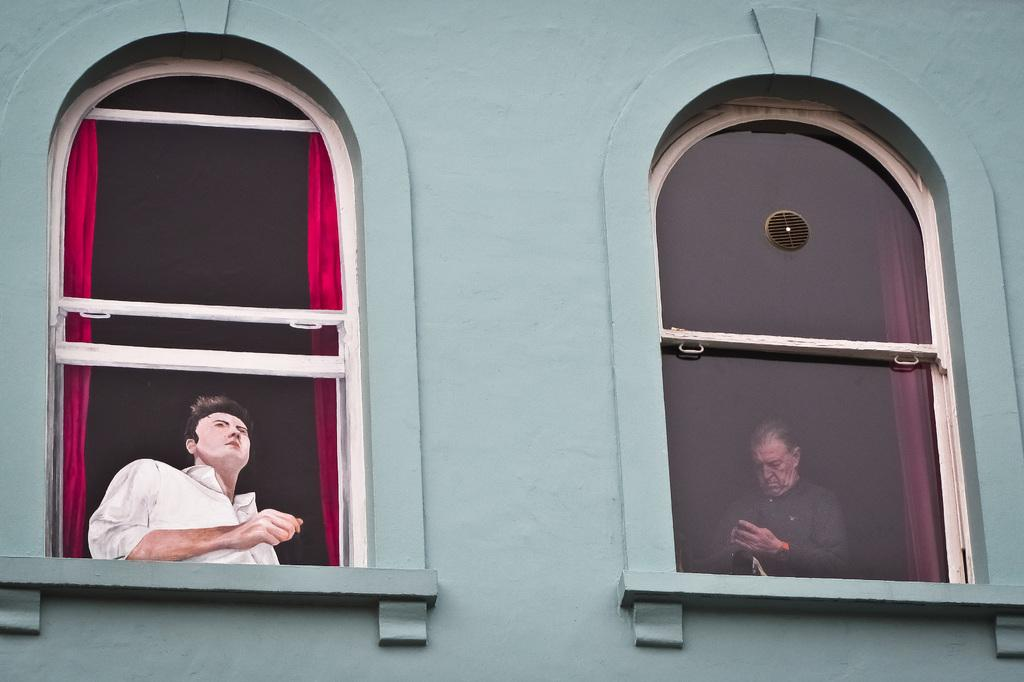What is located on the right side of the image? There is a wall and a glass window on the right side of the image. What can be seen through the glass window? A human is visible through the glass window. What is associated with the glass window? There is a curtain associated with the glass window. What is on the left side of the image? There is a painting on the left side of the image. Where is the sink located in the image? There is no sink present in the image. Is there any grass visible in the image? There is no grass visible in the image. 